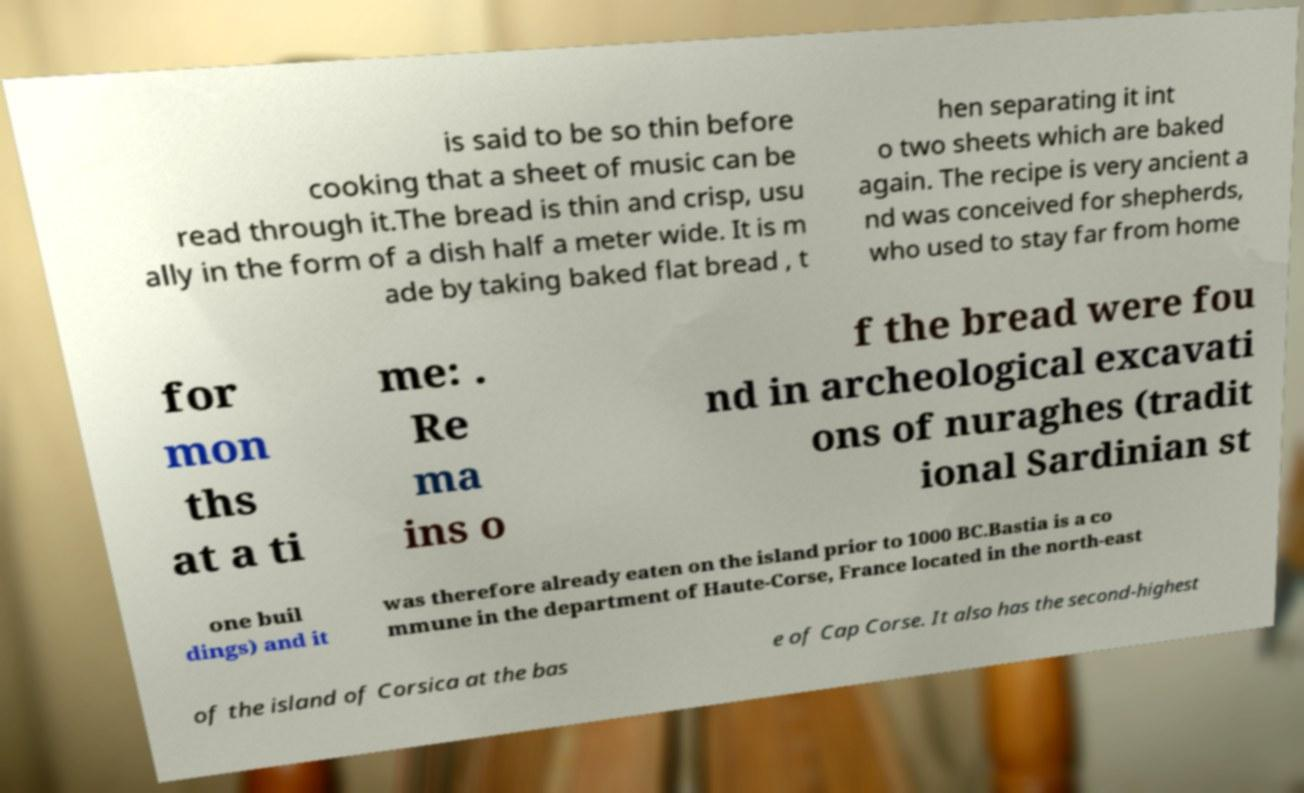Can you accurately transcribe the text from the provided image for me? is said to be so thin before cooking that a sheet of music can be read through it.The bread is thin and crisp, usu ally in the form of a dish half a meter wide. It is m ade by taking baked flat bread , t hen separating it int o two sheets which are baked again. The recipe is very ancient a nd was conceived for shepherds, who used to stay far from home for mon ths at a ti me: . Re ma ins o f the bread were fou nd in archeological excavati ons of nuraghes (tradit ional Sardinian st one buil dings) and it was therefore already eaten on the island prior to 1000 BC.Bastia is a co mmune in the department of Haute-Corse, France located in the north-east of the island of Corsica at the bas e of Cap Corse. It also has the second-highest 